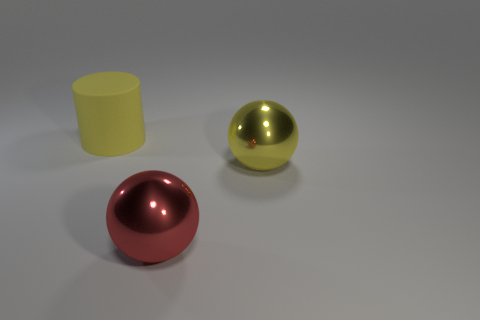Is there any other thing that has the same shape as the rubber thing?
Your answer should be very brief. No. What number of other objects are there of the same shape as the large yellow matte thing?
Keep it short and to the point. 0. Do the yellow metal ball and the cylinder have the same size?
Keep it short and to the point. Yes. Are there any tiny yellow rubber blocks?
Your answer should be compact. No. Is there anything else that has the same material as the big cylinder?
Provide a short and direct response. No. Is there a large yellow ball that has the same material as the red sphere?
Your answer should be compact. Yes. What is the material of the yellow cylinder that is the same size as the yellow shiny ball?
Offer a terse response. Rubber. How many large yellow things have the same shape as the big red thing?
Keep it short and to the point. 1. What material is the thing that is in front of the large yellow cylinder and on the left side of the yellow metallic thing?
Ensure brevity in your answer.  Metal. What number of rubber cylinders are the same size as the yellow metallic ball?
Your response must be concise. 1. 